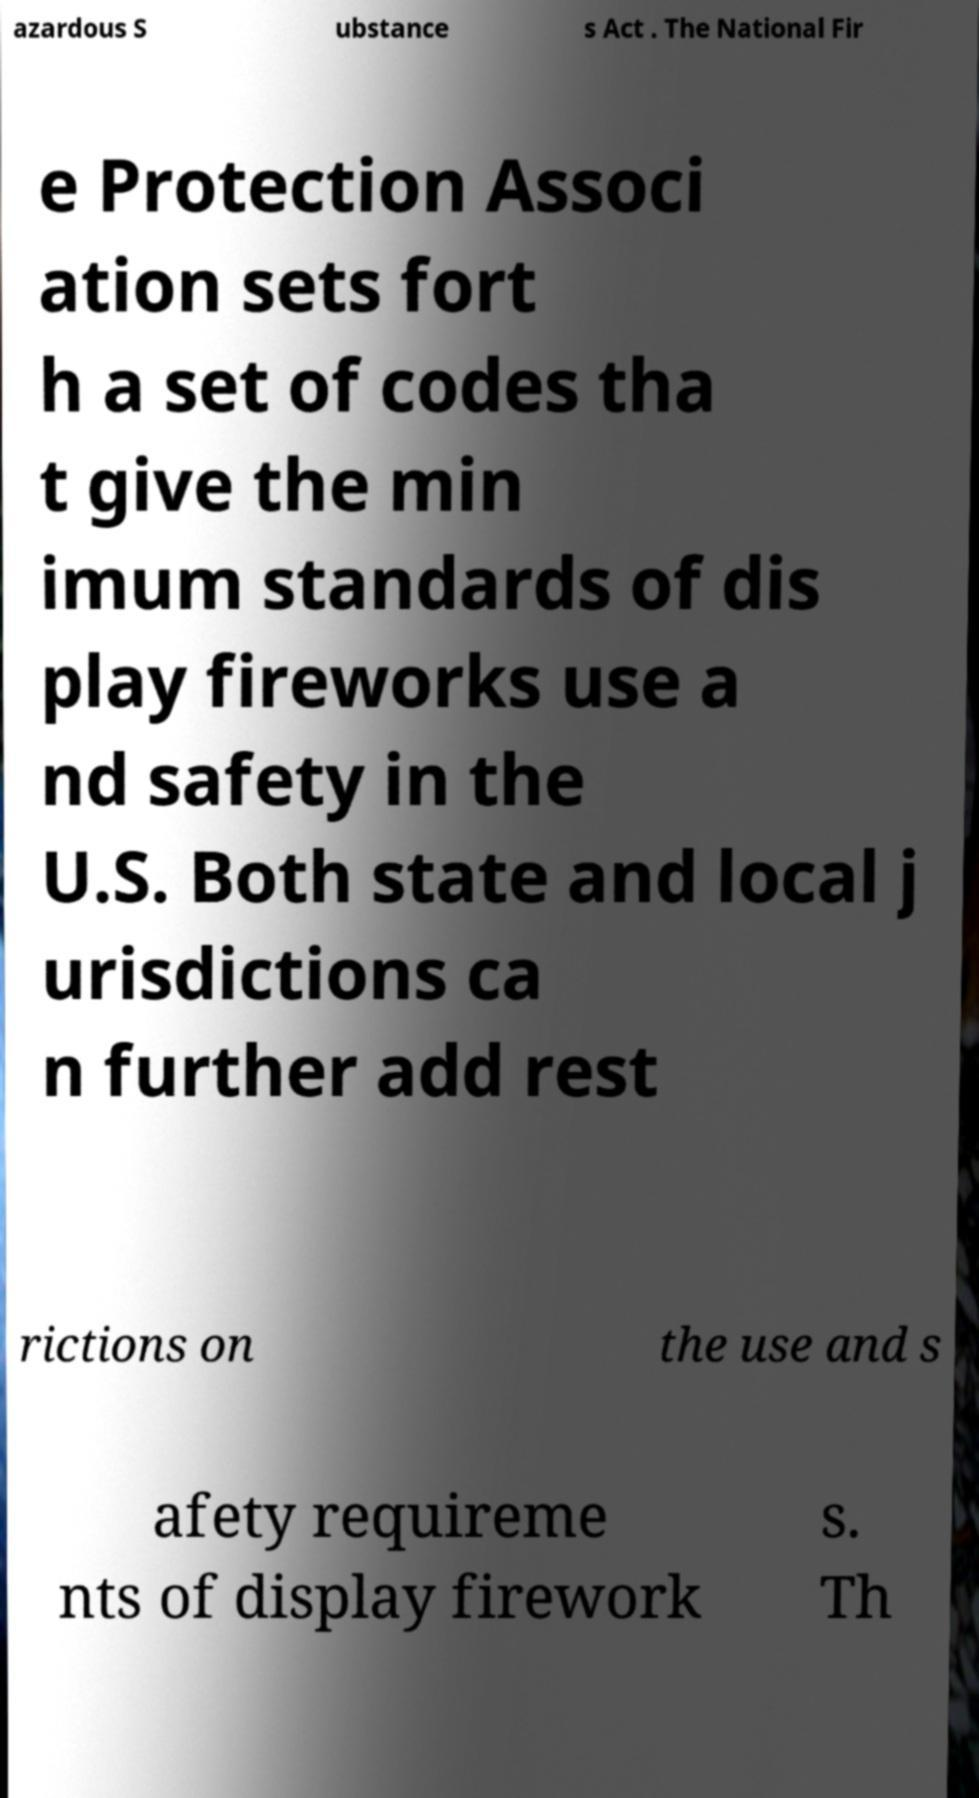I need the written content from this picture converted into text. Can you do that? azardous S ubstance s Act . The National Fir e Protection Associ ation sets fort h a set of codes tha t give the min imum standards of dis play fireworks use a nd safety in the U.S. Both state and local j urisdictions ca n further add rest rictions on the use and s afety requireme nts of display firework s. Th 